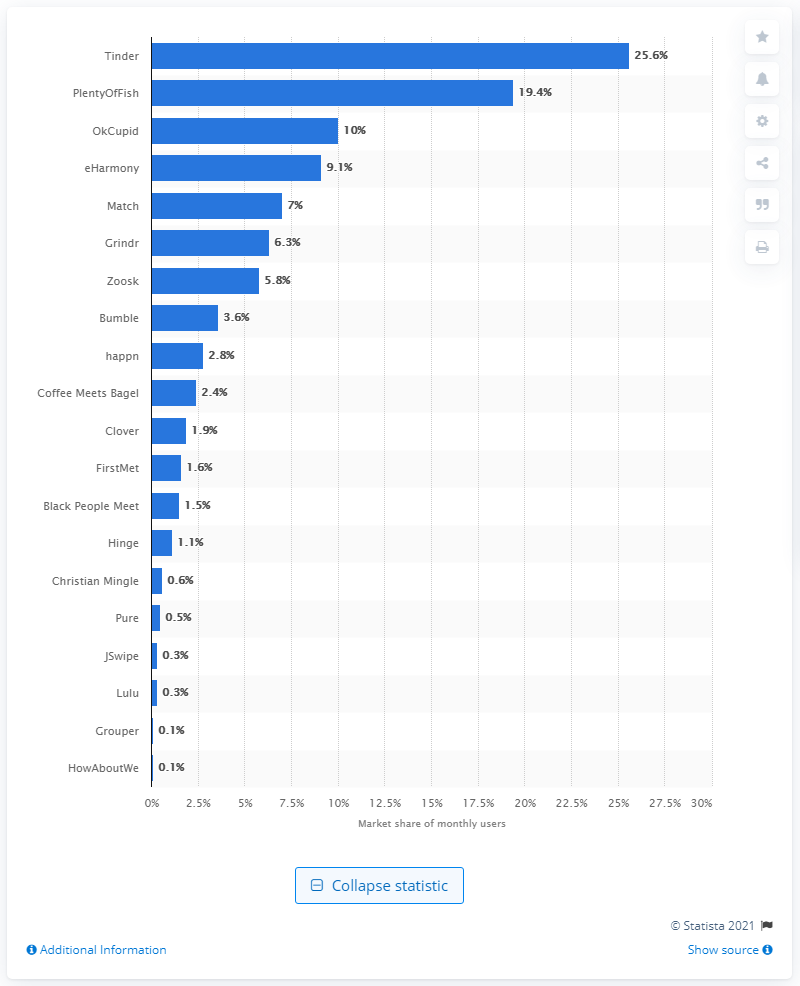Indicate a few pertinent items in this graphic. According to the given information, PlentyOfFish had a market share of 19.4% during a specific time period. The second most popular dating app was PlentyOfFish. In 2020, Tinder held a market share of 25.6% among all monthly active users of dating apps in the United States. 